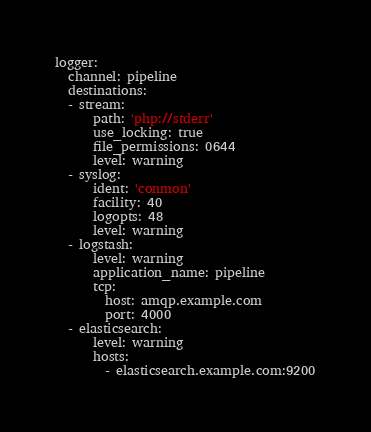Convert code to text. <code><loc_0><loc_0><loc_500><loc_500><_YAML_>logger:
  channel: pipeline
  destinations:
  - stream:
      path: 'php://stderr'
      use_locking: true
      file_permissions: 0644
      level: warning
  - syslog:
      ident: 'conmon'
      facility: 40
      logopts: 48
      level: warning
  - logstash:
      level: warning
      application_name: pipeline
      tcp:
        host: amqp.example.com
        port: 4000
  - elasticsearch:
      level: warning
      hosts:
        - elasticsearch.example.com:9200
</code> 